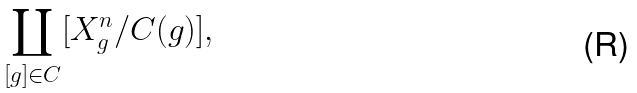Convert formula to latex. <formula><loc_0><loc_0><loc_500><loc_500>\coprod _ { [ g ] \in C } [ X ^ { n } _ { g } / C ( g ) ] ,</formula> 